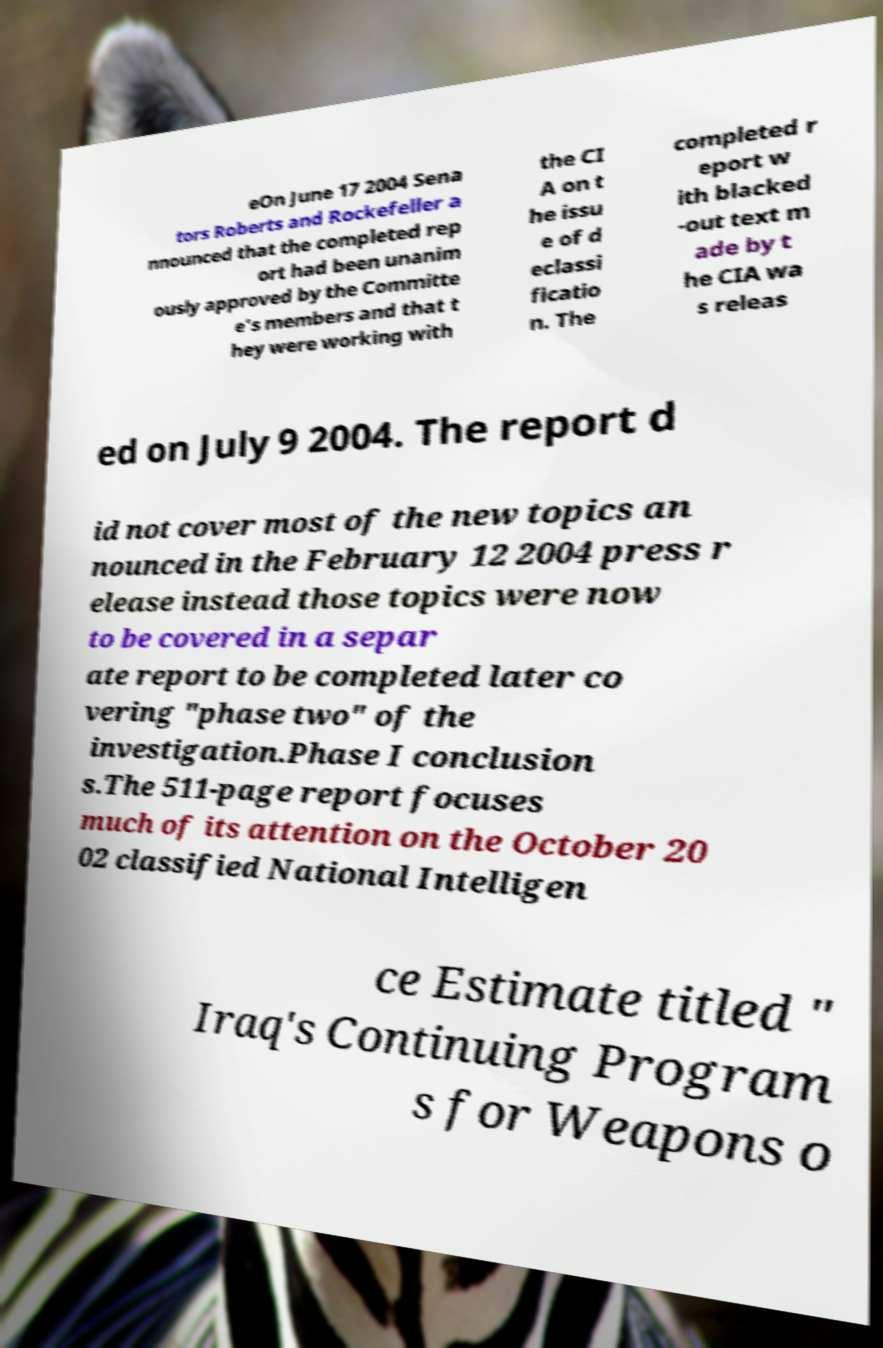Can you read and provide the text displayed in the image?This photo seems to have some interesting text. Can you extract and type it out for me? eOn June 17 2004 Sena tors Roberts and Rockefeller a nnounced that the completed rep ort had been unanim ously approved by the Committe e's members and that t hey were working with the CI A on t he issu e of d eclassi ficatio n. The completed r eport w ith blacked -out text m ade by t he CIA wa s releas ed on July 9 2004. The report d id not cover most of the new topics an nounced in the February 12 2004 press r elease instead those topics were now to be covered in a separ ate report to be completed later co vering "phase two" of the investigation.Phase I conclusion s.The 511-page report focuses much of its attention on the October 20 02 classified National Intelligen ce Estimate titled " Iraq's Continuing Program s for Weapons o 